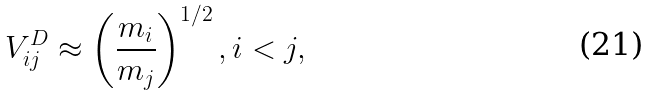Convert formula to latex. <formula><loc_0><loc_0><loc_500><loc_500>V ^ { D } _ { i j } \approx \left ( \frac { m _ { i } } { m _ { j } } \right ) ^ { 1 / 2 } , i < j ,</formula> 